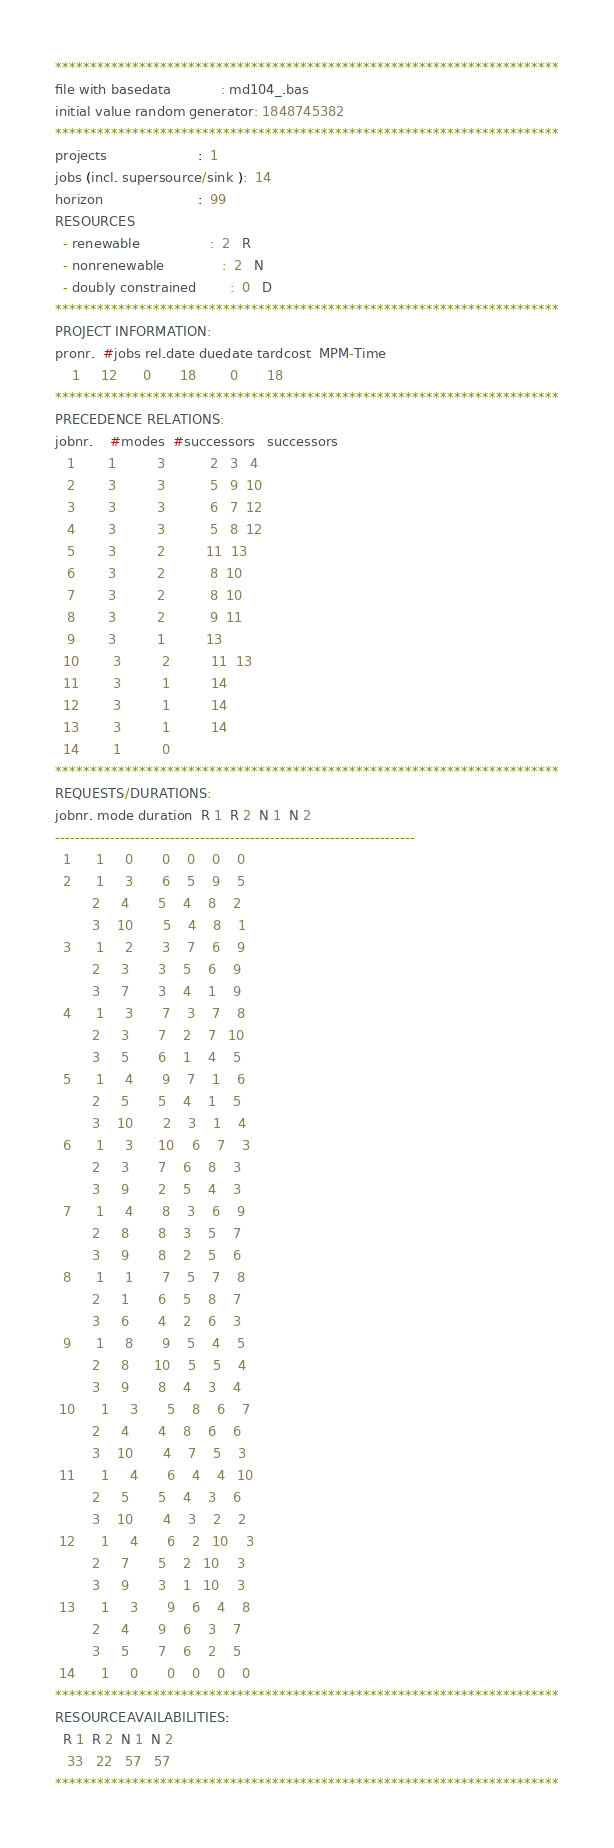Convert code to text. <code><loc_0><loc_0><loc_500><loc_500><_ObjectiveC_>************************************************************************
file with basedata            : md104_.bas
initial value random generator: 1848745382
************************************************************************
projects                      :  1
jobs (incl. supersource/sink ):  14
horizon                       :  99
RESOURCES
  - renewable                 :  2   R
  - nonrenewable              :  2   N
  - doubly constrained        :  0   D
************************************************************************
PROJECT INFORMATION:
pronr.  #jobs rel.date duedate tardcost  MPM-Time
    1     12      0       18        0       18
************************************************************************
PRECEDENCE RELATIONS:
jobnr.    #modes  #successors   successors
   1        1          3           2   3   4
   2        3          3           5   9  10
   3        3          3           6   7  12
   4        3          3           5   8  12
   5        3          2          11  13
   6        3          2           8  10
   7        3          2           8  10
   8        3          2           9  11
   9        3          1          13
  10        3          2          11  13
  11        3          1          14
  12        3          1          14
  13        3          1          14
  14        1          0        
************************************************************************
REQUESTS/DURATIONS:
jobnr. mode duration  R 1  R 2  N 1  N 2
------------------------------------------------------------------------
  1      1     0       0    0    0    0
  2      1     3       6    5    9    5
         2     4       5    4    8    2
         3    10       5    4    8    1
  3      1     2       3    7    6    9
         2     3       3    5    6    9
         3     7       3    4    1    9
  4      1     3       7    3    7    8
         2     3       7    2    7   10
         3     5       6    1    4    5
  5      1     4       9    7    1    6
         2     5       5    4    1    5
         3    10       2    3    1    4
  6      1     3      10    6    7    3
         2     3       7    6    8    3
         3     9       2    5    4    3
  7      1     4       8    3    6    9
         2     8       8    3    5    7
         3     9       8    2    5    6
  8      1     1       7    5    7    8
         2     1       6    5    8    7
         3     6       4    2    6    3
  9      1     8       9    5    4    5
         2     8      10    5    5    4
         3     9       8    4    3    4
 10      1     3       5    8    6    7
         2     4       4    8    6    6
         3    10       4    7    5    3
 11      1     4       6    4    4   10
         2     5       5    4    3    6
         3    10       4    3    2    2
 12      1     4       6    2   10    3
         2     7       5    2   10    3
         3     9       3    1   10    3
 13      1     3       9    6    4    8
         2     4       9    6    3    7
         3     5       7    6    2    5
 14      1     0       0    0    0    0
************************************************************************
RESOURCEAVAILABILITIES:
  R 1  R 2  N 1  N 2
   33   22   57   57
************************************************************************
</code> 